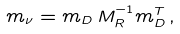<formula> <loc_0><loc_0><loc_500><loc_500>m _ { \nu } = m _ { D } \, M _ { R } ^ { - 1 } m ^ { T } _ { D } \, ,</formula> 